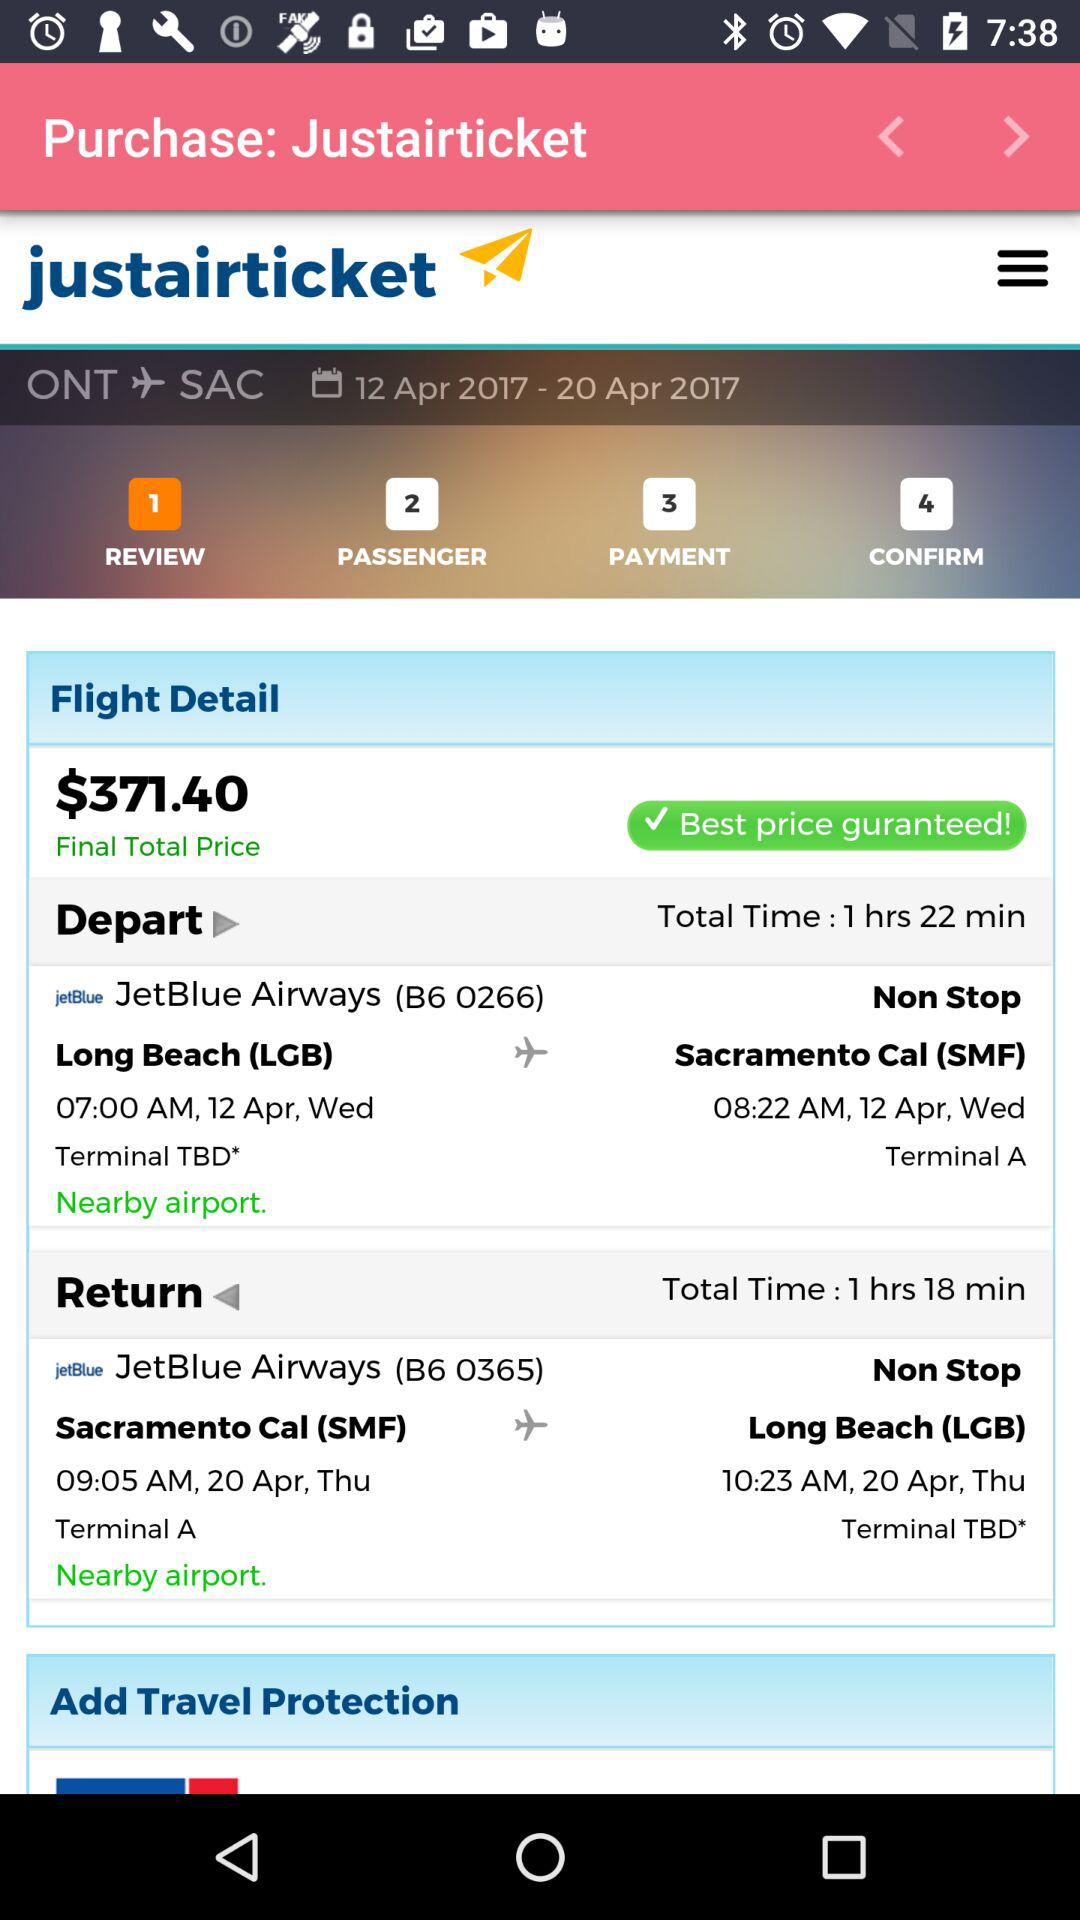What is the arrival time for JetBlue Airways (B6 0266)? The arrival time is 08:22 AM. 